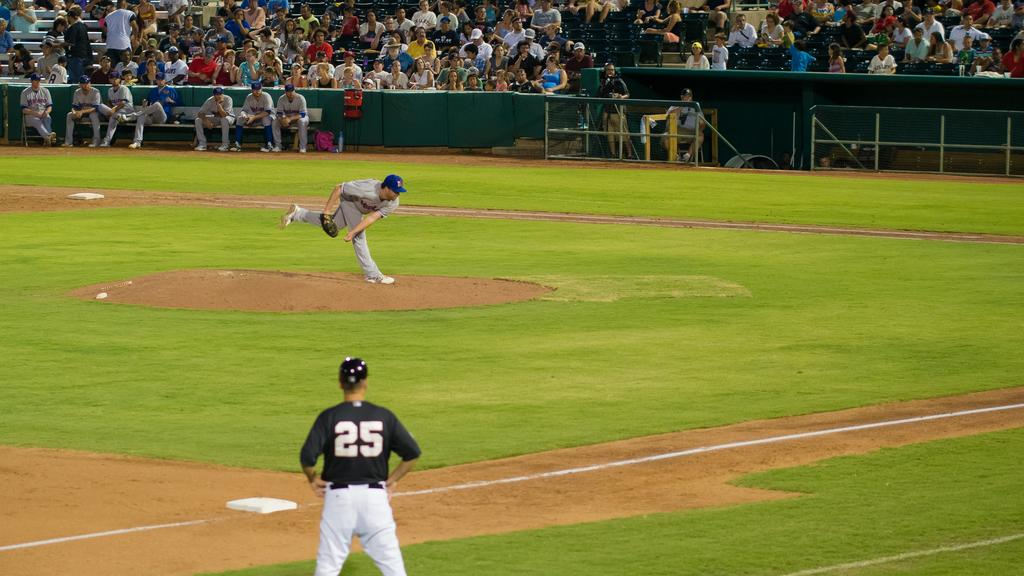<image>
Create a compact narrative representing the image presented. Player number 25 from the opposing teams observes the pitcher throwing. 